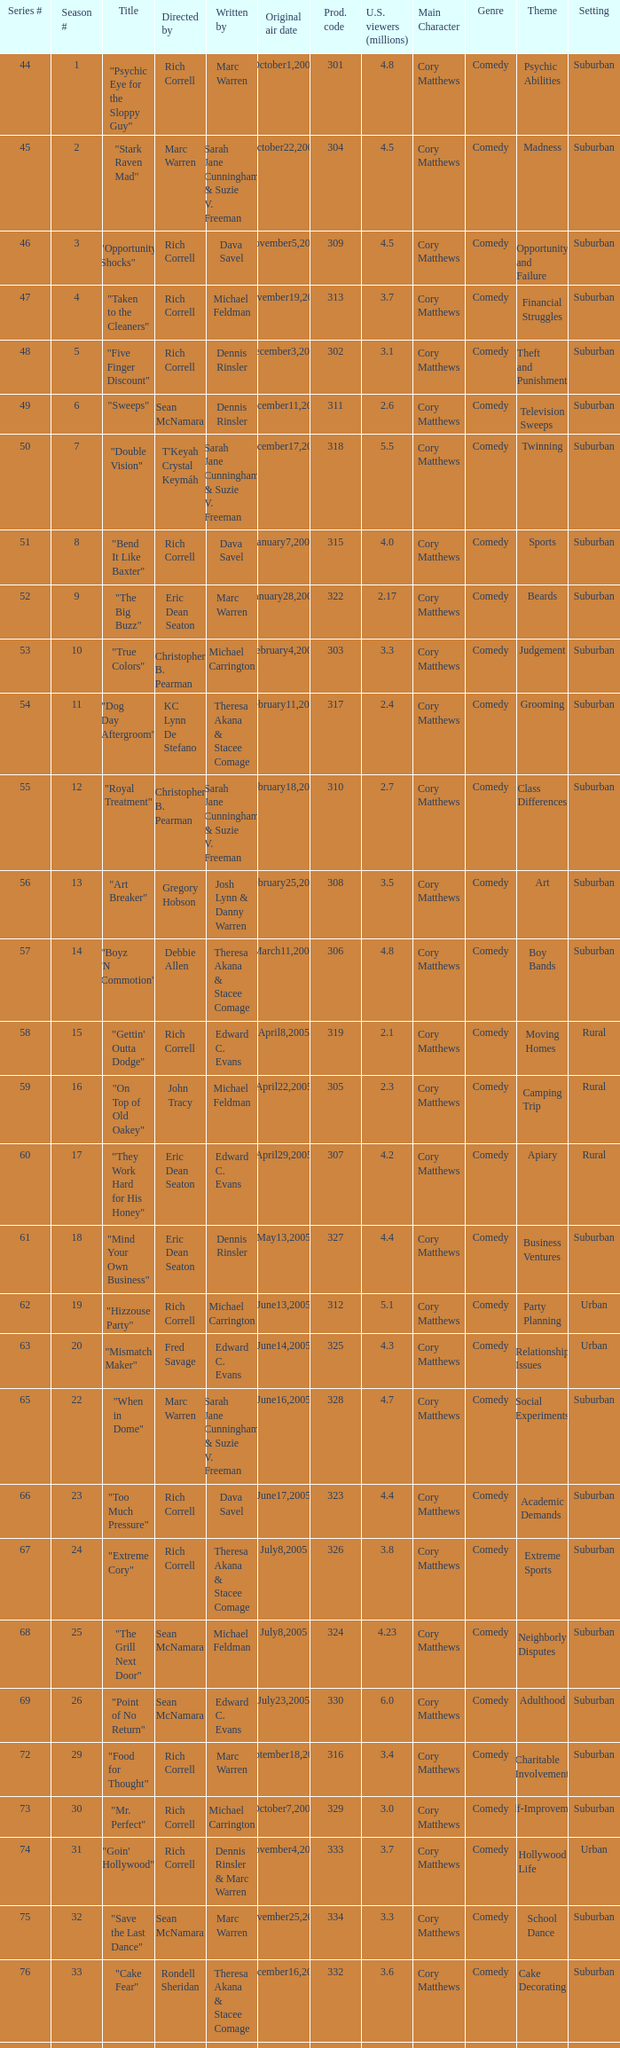What is the heading of the episode overseen by rich correll and composed by dennis rinsler? "Five Finger Discount". 